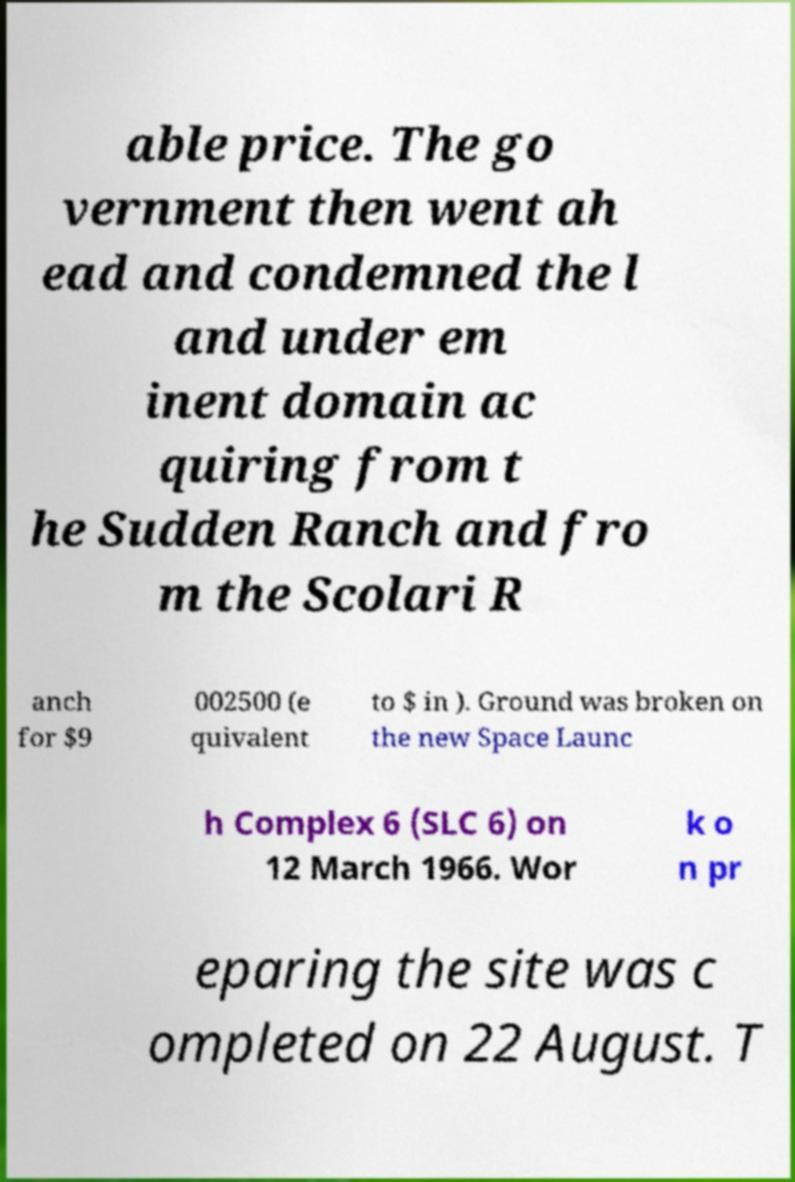For documentation purposes, I need the text within this image transcribed. Could you provide that? able price. The go vernment then went ah ead and condemned the l and under em inent domain ac quiring from t he Sudden Ranch and fro m the Scolari R anch for $9 002500 (e quivalent to $ in ). Ground was broken on the new Space Launc h Complex 6 (SLC 6) on 12 March 1966. Wor k o n pr eparing the site was c ompleted on 22 August. T 